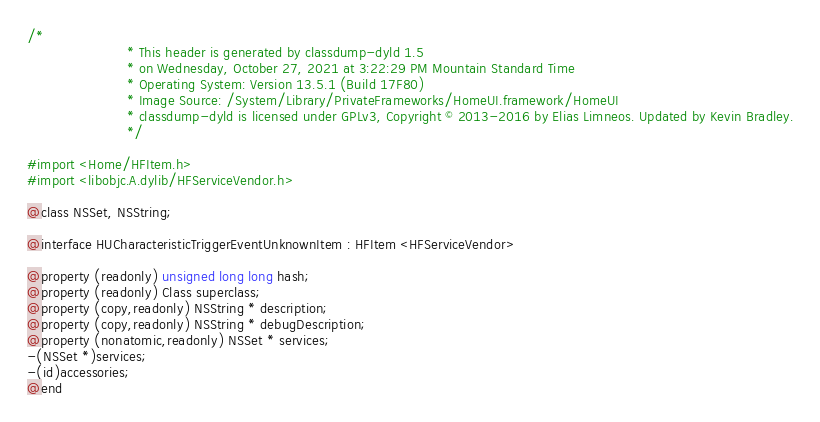<code> <loc_0><loc_0><loc_500><loc_500><_C_>/*
                       * This header is generated by classdump-dyld 1.5
                       * on Wednesday, October 27, 2021 at 3:22:29 PM Mountain Standard Time
                       * Operating System: Version 13.5.1 (Build 17F80)
                       * Image Source: /System/Library/PrivateFrameworks/HomeUI.framework/HomeUI
                       * classdump-dyld is licensed under GPLv3, Copyright © 2013-2016 by Elias Limneos. Updated by Kevin Bradley.
                       */

#import <Home/HFItem.h>
#import <libobjc.A.dylib/HFServiceVendor.h>

@class NSSet, NSString;

@interface HUCharacteristicTriggerEventUnknownItem : HFItem <HFServiceVendor>

@property (readonly) unsigned long long hash; 
@property (readonly) Class superclass; 
@property (copy,readonly) NSString * description; 
@property (copy,readonly) NSString * debugDescription; 
@property (nonatomic,readonly) NSSet * services; 
-(NSSet *)services;
-(id)accessories;
@end

</code> 